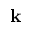Convert formula to latex. <formula><loc_0><loc_0><loc_500><loc_500>k</formula> 